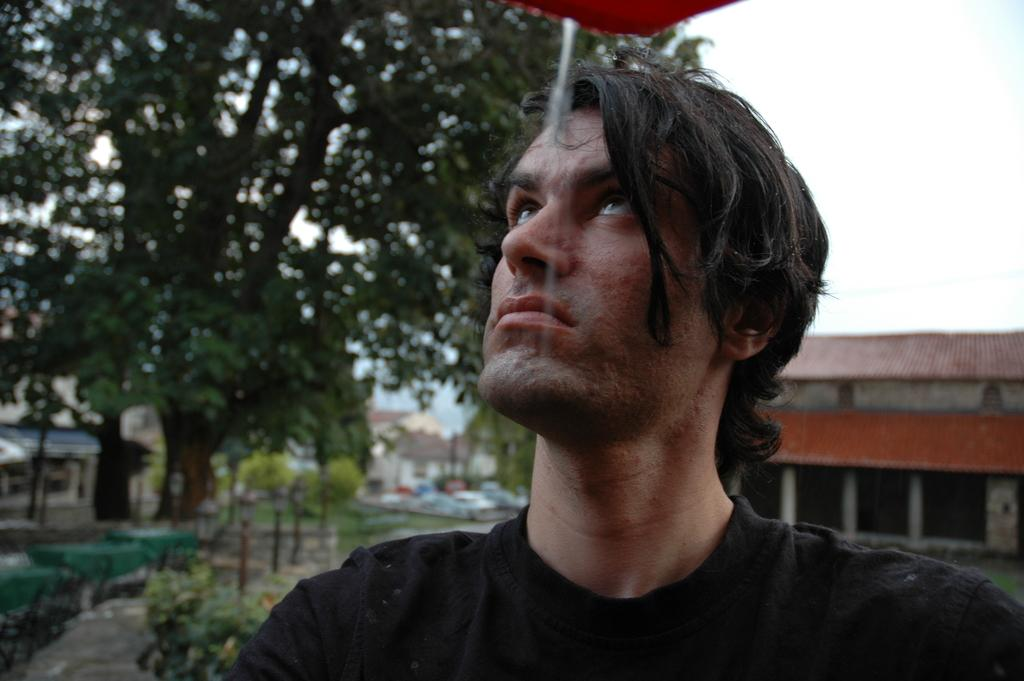Who is present in the image? There is a man in the image. What can be seen behind the man? There are trees and houses behind the man. What is visible in the sky in the image? The sky is visible in the image. What color is the object at the top of the image? There is a red color object at the top of the image. What type of wound can be seen on the monkey in the image? There is no monkey present in the image, and therefore no wound can be observed. 